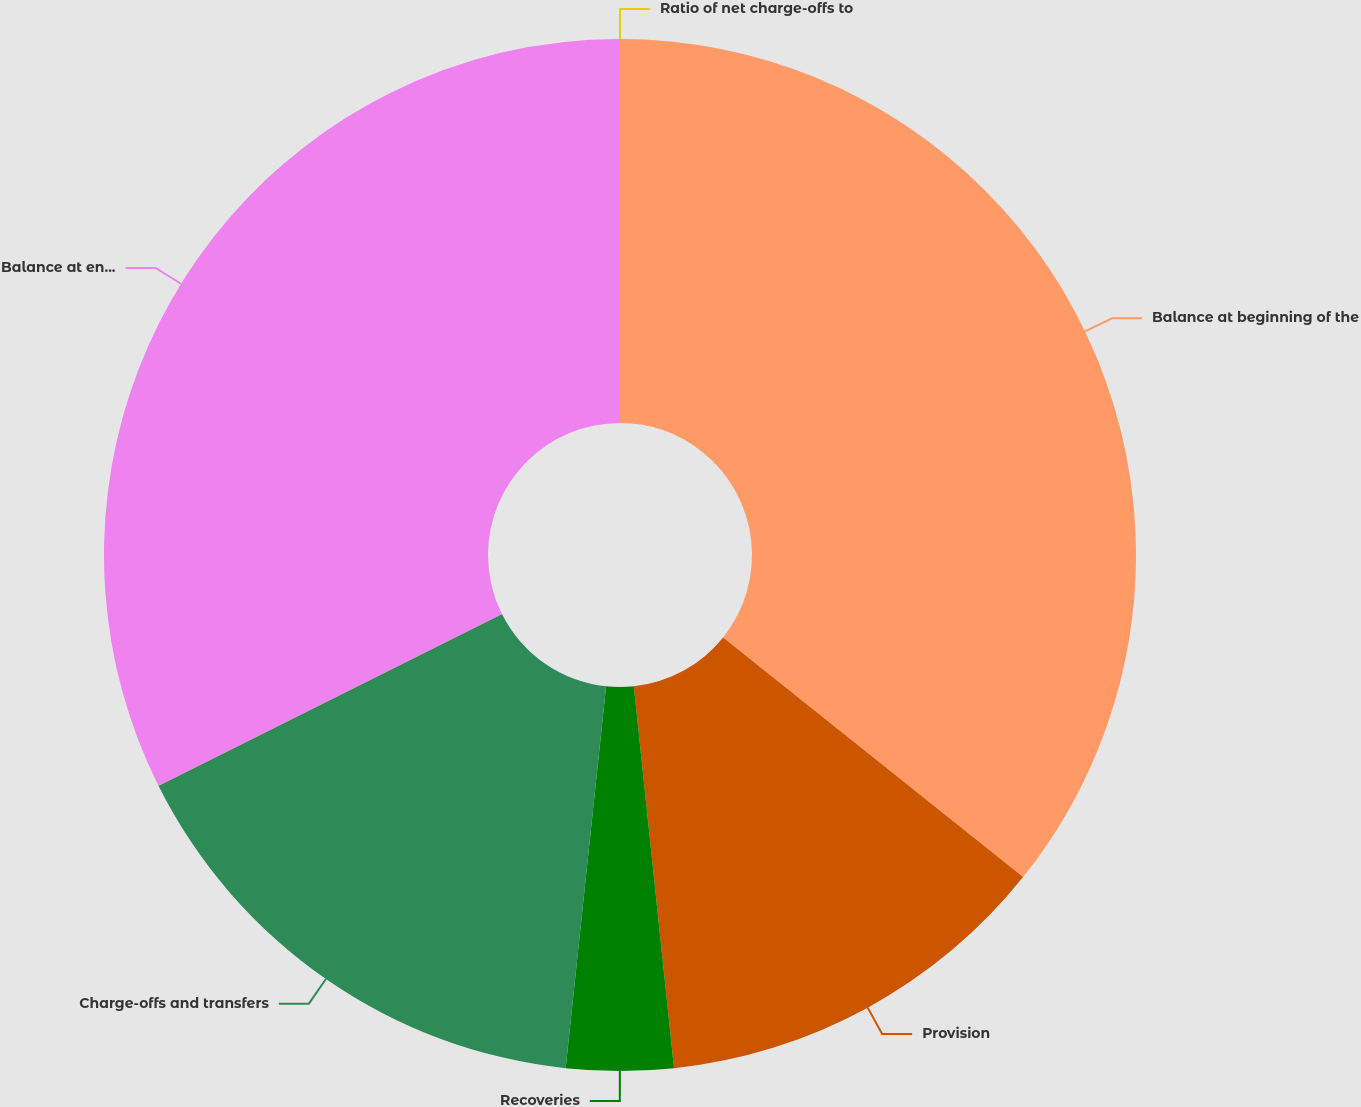<chart> <loc_0><loc_0><loc_500><loc_500><pie_chart><fcel>Balance at beginning of the<fcel>Provision<fcel>Recoveries<fcel>Charge-offs and transfers<fcel>Balance at end of the year<fcel>Ratio of net charge-offs to<nl><fcel>35.73%<fcel>12.6%<fcel>3.35%<fcel>15.94%<fcel>32.38%<fcel>0.0%<nl></chart> 